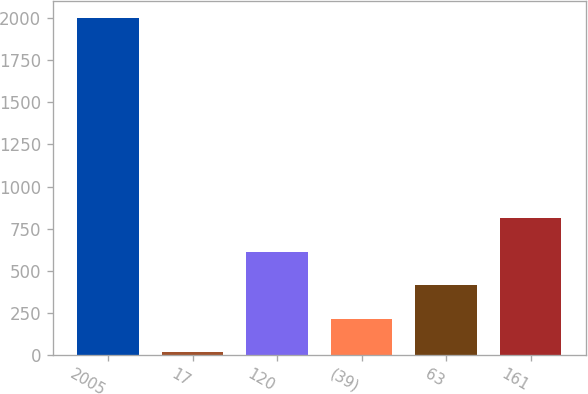<chart> <loc_0><loc_0><loc_500><loc_500><bar_chart><fcel>2005<fcel>17<fcel>120<fcel>(39)<fcel>63<fcel>161<nl><fcel>2003<fcel>17<fcel>612.8<fcel>215.6<fcel>414.2<fcel>811.4<nl></chart> 